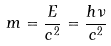<formula> <loc_0><loc_0><loc_500><loc_500>m = \frac { E } { c ^ { 2 } } = \frac { h \nu } { c ^ { 2 } }</formula> 